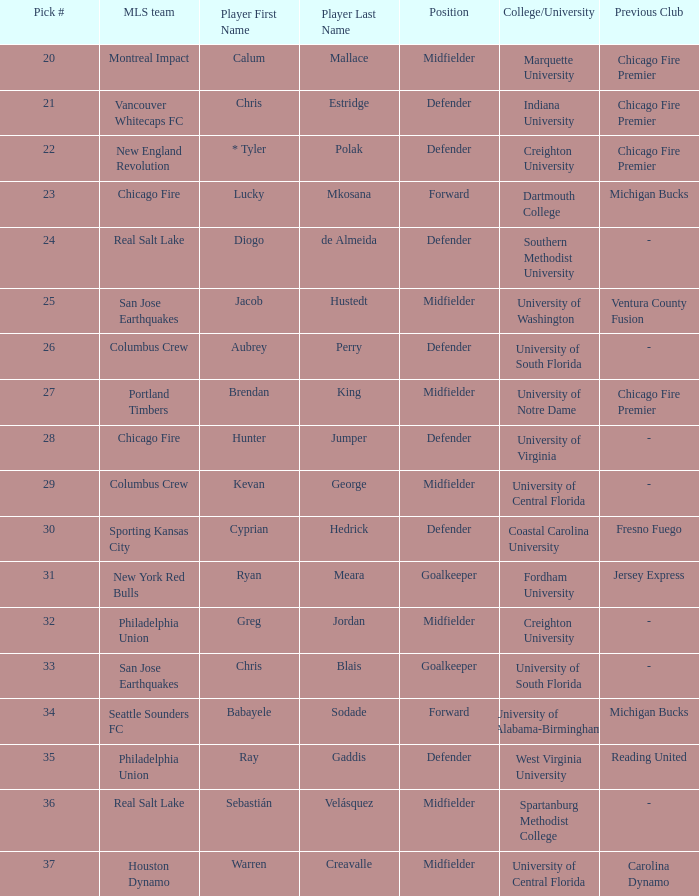Could you parse the entire table as a dict? {'header': ['Pick #', 'MLS team', 'Player First Name', 'Player Last Name', 'Position', 'College/University', 'Previous Club'], 'rows': [['20', 'Montreal Impact', 'Calum', 'Mallace', 'Midfielder', 'Marquette University', 'Chicago Fire Premier'], ['21', 'Vancouver Whitecaps FC', 'Chris', 'Estridge', 'Defender', 'Indiana University', 'Chicago Fire Premier'], ['22', 'New England Revolution', '* Tyler', 'Polak', 'Defender', 'Creighton University', 'Chicago Fire Premier'], ['23', 'Chicago Fire', 'Lucky', 'Mkosana', 'Forward', 'Dartmouth College', 'Michigan Bucks'], ['24', 'Real Salt Lake', 'Diogo', 'de Almeida', 'Defender', 'Southern Methodist University', '-'], ['25', 'San Jose Earthquakes', 'Jacob', 'Hustedt', 'Midfielder', 'University of Washington', 'Ventura County Fusion'], ['26', 'Columbus Crew', 'Aubrey', 'Perry', 'Defender', 'University of South Florida', '-'], ['27', 'Portland Timbers', 'Brendan', 'King', 'Midfielder', 'University of Notre Dame', 'Chicago Fire Premier'], ['28', 'Chicago Fire', 'Hunter', 'Jumper', 'Defender', 'University of Virginia', '-'], ['29', 'Columbus Crew', 'Kevan', 'George', 'Midfielder', 'University of Central Florida', '-'], ['30', 'Sporting Kansas City', 'Cyprian', 'Hedrick', 'Defender', 'Coastal Carolina University', 'Fresno Fuego'], ['31', 'New York Red Bulls', 'Ryan', 'Meara', 'Goalkeeper', 'Fordham University', 'Jersey Express'], ['32', 'Philadelphia Union', 'Greg', 'Jordan', 'Midfielder', 'Creighton University', '-'], ['33', 'San Jose Earthquakes', 'Chris', 'Blais', 'Goalkeeper', 'University of South Florida', '-'], ['34', 'Seattle Sounders FC', 'Babayele', 'Sodade', 'Forward', 'University of Alabama-Birmingham', 'Michigan Bucks'], ['35', 'Philadelphia Union', 'Ray', 'Gaddis', 'Defender', 'West Virginia University', 'Reading United'], ['36', 'Real Salt Lake', 'Sebastián', 'Velásquez', 'Midfielder', 'Spartanburg Methodist College', '-'], ['37', 'Houston Dynamo', 'Warren', 'Creavalle', 'Midfielder', 'University of Central Florida', 'Carolina Dynamo']]} What was the selection number for real salt lake? 24.0. 